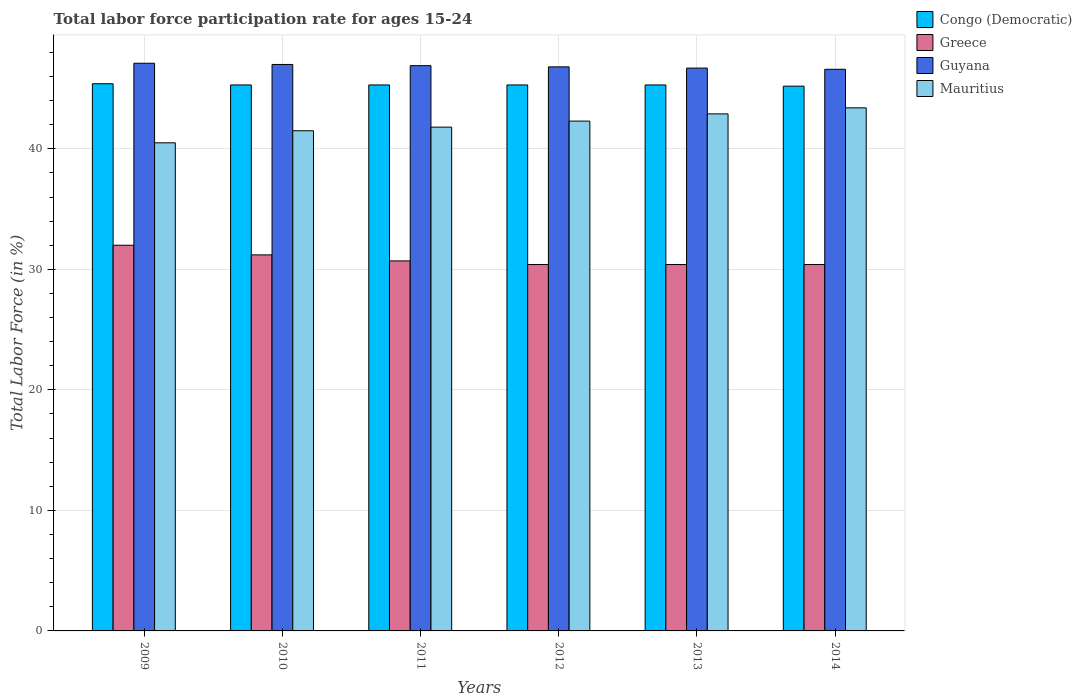How many groups of bars are there?
Keep it short and to the point. 6. Are the number of bars on each tick of the X-axis equal?
Ensure brevity in your answer.  Yes. How many bars are there on the 4th tick from the left?
Give a very brief answer. 4. What is the label of the 3rd group of bars from the left?
Give a very brief answer. 2011. In how many cases, is the number of bars for a given year not equal to the number of legend labels?
Keep it short and to the point. 0. Across all years, what is the maximum labor force participation rate in Mauritius?
Your answer should be compact. 43.4. Across all years, what is the minimum labor force participation rate in Mauritius?
Make the answer very short. 40.5. In which year was the labor force participation rate in Congo (Democratic) minimum?
Provide a short and direct response. 2014. What is the total labor force participation rate in Congo (Democratic) in the graph?
Keep it short and to the point. 271.8. What is the difference between the labor force participation rate in Greece in 2009 and that in 2014?
Provide a succinct answer. 1.6. What is the difference between the labor force participation rate in Greece in 2014 and the labor force participation rate in Guyana in 2013?
Give a very brief answer. -16.3. What is the average labor force participation rate in Greece per year?
Provide a short and direct response. 30.85. In the year 2014, what is the difference between the labor force participation rate in Mauritius and labor force participation rate in Greece?
Provide a short and direct response. 13. What is the ratio of the labor force participation rate in Guyana in 2009 to that in 2010?
Your answer should be very brief. 1. Is the difference between the labor force participation rate in Mauritius in 2011 and 2014 greater than the difference between the labor force participation rate in Greece in 2011 and 2014?
Offer a terse response. No. What is the difference between the highest and the second highest labor force participation rate in Mauritius?
Provide a succinct answer. 0.5. What is the difference between the highest and the lowest labor force participation rate in Greece?
Provide a short and direct response. 1.6. In how many years, is the labor force participation rate in Mauritius greater than the average labor force participation rate in Mauritius taken over all years?
Provide a succinct answer. 3. Is it the case that in every year, the sum of the labor force participation rate in Guyana and labor force participation rate in Congo (Democratic) is greater than the sum of labor force participation rate in Mauritius and labor force participation rate in Greece?
Provide a short and direct response. Yes. What does the 1st bar from the left in 2014 represents?
Ensure brevity in your answer.  Congo (Democratic). What does the 2nd bar from the right in 2012 represents?
Keep it short and to the point. Guyana. Is it the case that in every year, the sum of the labor force participation rate in Guyana and labor force participation rate in Greece is greater than the labor force participation rate in Congo (Democratic)?
Give a very brief answer. Yes. How many bars are there?
Provide a short and direct response. 24. What is the difference between two consecutive major ticks on the Y-axis?
Your response must be concise. 10. Are the values on the major ticks of Y-axis written in scientific E-notation?
Offer a terse response. No. How many legend labels are there?
Your response must be concise. 4. How are the legend labels stacked?
Ensure brevity in your answer.  Vertical. What is the title of the graph?
Your answer should be very brief. Total labor force participation rate for ages 15-24. What is the label or title of the X-axis?
Your answer should be compact. Years. What is the Total Labor Force (in %) of Congo (Democratic) in 2009?
Make the answer very short. 45.4. What is the Total Labor Force (in %) of Guyana in 2009?
Offer a terse response. 47.1. What is the Total Labor Force (in %) in Mauritius in 2009?
Your answer should be compact. 40.5. What is the Total Labor Force (in %) of Congo (Democratic) in 2010?
Offer a very short reply. 45.3. What is the Total Labor Force (in %) of Greece in 2010?
Your answer should be compact. 31.2. What is the Total Labor Force (in %) of Guyana in 2010?
Your response must be concise. 47. What is the Total Labor Force (in %) of Mauritius in 2010?
Your answer should be very brief. 41.5. What is the Total Labor Force (in %) of Congo (Democratic) in 2011?
Ensure brevity in your answer.  45.3. What is the Total Labor Force (in %) in Greece in 2011?
Your response must be concise. 30.7. What is the Total Labor Force (in %) in Guyana in 2011?
Offer a very short reply. 46.9. What is the Total Labor Force (in %) in Mauritius in 2011?
Your answer should be very brief. 41.8. What is the Total Labor Force (in %) in Congo (Democratic) in 2012?
Provide a succinct answer. 45.3. What is the Total Labor Force (in %) in Greece in 2012?
Provide a succinct answer. 30.4. What is the Total Labor Force (in %) of Guyana in 2012?
Offer a very short reply. 46.8. What is the Total Labor Force (in %) of Mauritius in 2012?
Provide a succinct answer. 42.3. What is the Total Labor Force (in %) of Congo (Democratic) in 2013?
Give a very brief answer. 45.3. What is the Total Labor Force (in %) in Greece in 2013?
Provide a succinct answer. 30.4. What is the Total Labor Force (in %) of Guyana in 2013?
Offer a terse response. 46.7. What is the Total Labor Force (in %) in Mauritius in 2013?
Provide a short and direct response. 42.9. What is the Total Labor Force (in %) in Congo (Democratic) in 2014?
Provide a succinct answer. 45.2. What is the Total Labor Force (in %) of Greece in 2014?
Provide a succinct answer. 30.4. What is the Total Labor Force (in %) of Guyana in 2014?
Your response must be concise. 46.6. What is the Total Labor Force (in %) in Mauritius in 2014?
Provide a succinct answer. 43.4. Across all years, what is the maximum Total Labor Force (in %) of Congo (Democratic)?
Provide a short and direct response. 45.4. Across all years, what is the maximum Total Labor Force (in %) of Greece?
Make the answer very short. 32. Across all years, what is the maximum Total Labor Force (in %) in Guyana?
Your answer should be very brief. 47.1. Across all years, what is the maximum Total Labor Force (in %) of Mauritius?
Keep it short and to the point. 43.4. Across all years, what is the minimum Total Labor Force (in %) in Congo (Democratic)?
Keep it short and to the point. 45.2. Across all years, what is the minimum Total Labor Force (in %) in Greece?
Keep it short and to the point. 30.4. Across all years, what is the minimum Total Labor Force (in %) in Guyana?
Provide a succinct answer. 46.6. Across all years, what is the minimum Total Labor Force (in %) in Mauritius?
Provide a short and direct response. 40.5. What is the total Total Labor Force (in %) in Congo (Democratic) in the graph?
Make the answer very short. 271.8. What is the total Total Labor Force (in %) of Greece in the graph?
Offer a very short reply. 185.1. What is the total Total Labor Force (in %) in Guyana in the graph?
Provide a short and direct response. 281.1. What is the total Total Labor Force (in %) in Mauritius in the graph?
Provide a short and direct response. 252.4. What is the difference between the Total Labor Force (in %) in Greece in 2009 and that in 2010?
Your answer should be very brief. 0.8. What is the difference between the Total Labor Force (in %) of Greece in 2009 and that in 2011?
Keep it short and to the point. 1.3. What is the difference between the Total Labor Force (in %) in Guyana in 2009 and that in 2011?
Offer a very short reply. 0.2. What is the difference between the Total Labor Force (in %) of Mauritius in 2009 and that in 2011?
Provide a succinct answer. -1.3. What is the difference between the Total Labor Force (in %) of Congo (Democratic) in 2009 and that in 2012?
Your response must be concise. 0.1. What is the difference between the Total Labor Force (in %) of Congo (Democratic) in 2009 and that in 2013?
Your response must be concise. 0.1. What is the difference between the Total Labor Force (in %) in Guyana in 2009 and that in 2013?
Ensure brevity in your answer.  0.4. What is the difference between the Total Labor Force (in %) of Greece in 2009 and that in 2014?
Provide a short and direct response. 1.6. What is the difference between the Total Labor Force (in %) of Mauritius in 2009 and that in 2014?
Give a very brief answer. -2.9. What is the difference between the Total Labor Force (in %) of Congo (Democratic) in 2010 and that in 2011?
Your response must be concise. 0. What is the difference between the Total Labor Force (in %) of Greece in 2010 and that in 2011?
Your answer should be compact. 0.5. What is the difference between the Total Labor Force (in %) of Guyana in 2010 and that in 2011?
Keep it short and to the point. 0.1. What is the difference between the Total Labor Force (in %) in Mauritius in 2010 and that in 2011?
Provide a succinct answer. -0.3. What is the difference between the Total Labor Force (in %) of Greece in 2010 and that in 2012?
Your answer should be very brief. 0.8. What is the difference between the Total Labor Force (in %) in Guyana in 2010 and that in 2012?
Provide a succinct answer. 0.2. What is the difference between the Total Labor Force (in %) of Greece in 2010 and that in 2013?
Offer a very short reply. 0.8. What is the difference between the Total Labor Force (in %) of Guyana in 2010 and that in 2013?
Your answer should be very brief. 0.3. What is the difference between the Total Labor Force (in %) of Mauritius in 2010 and that in 2013?
Make the answer very short. -1.4. What is the difference between the Total Labor Force (in %) of Greece in 2010 and that in 2014?
Provide a short and direct response. 0.8. What is the difference between the Total Labor Force (in %) of Guyana in 2010 and that in 2014?
Give a very brief answer. 0.4. What is the difference between the Total Labor Force (in %) in Mauritius in 2010 and that in 2014?
Your response must be concise. -1.9. What is the difference between the Total Labor Force (in %) in Congo (Democratic) in 2011 and that in 2012?
Ensure brevity in your answer.  0. What is the difference between the Total Labor Force (in %) in Mauritius in 2011 and that in 2012?
Your response must be concise. -0.5. What is the difference between the Total Labor Force (in %) in Greece in 2011 and that in 2013?
Offer a very short reply. 0.3. What is the difference between the Total Labor Force (in %) of Mauritius in 2011 and that in 2013?
Offer a very short reply. -1.1. What is the difference between the Total Labor Force (in %) of Congo (Democratic) in 2011 and that in 2014?
Offer a very short reply. 0.1. What is the difference between the Total Labor Force (in %) in Greece in 2011 and that in 2014?
Provide a succinct answer. 0.3. What is the difference between the Total Labor Force (in %) in Mauritius in 2011 and that in 2014?
Ensure brevity in your answer.  -1.6. What is the difference between the Total Labor Force (in %) of Congo (Democratic) in 2012 and that in 2013?
Give a very brief answer. 0. What is the difference between the Total Labor Force (in %) of Greece in 2012 and that in 2013?
Make the answer very short. 0. What is the difference between the Total Labor Force (in %) of Congo (Democratic) in 2012 and that in 2014?
Offer a terse response. 0.1. What is the difference between the Total Labor Force (in %) in Guyana in 2012 and that in 2014?
Provide a succinct answer. 0.2. What is the difference between the Total Labor Force (in %) of Congo (Democratic) in 2013 and that in 2014?
Keep it short and to the point. 0.1. What is the difference between the Total Labor Force (in %) of Greece in 2013 and that in 2014?
Your response must be concise. 0. What is the difference between the Total Labor Force (in %) of Mauritius in 2013 and that in 2014?
Provide a succinct answer. -0.5. What is the difference between the Total Labor Force (in %) of Congo (Democratic) in 2009 and the Total Labor Force (in %) of Greece in 2010?
Your answer should be very brief. 14.2. What is the difference between the Total Labor Force (in %) in Greece in 2009 and the Total Labor Force (in %) in Mauritius in 2010?
Provide a succinct answer. -9.5. What is the difference between the Total Labor Force (in %) in Guyana in 2009 and the Total Labor Force (in %) in Mauritius in 2010?
Offer a terse response. 5.6. What is the difference between the Total Labor Force (in %) in Greece in 2009 and the Total Labor Force (in %) in Guyana in 2011?
Ensure brevity in your answer.  -14.9. What is the difference between the Total Labor Force (in %) of Guyana in 2009 and the Total Labor Force (in %) of Mauritius in 2011?
Your answer should be compact. 5.3. What is the difference between the Total Labor Force (in %) of Congo (Democratic) in 2009 and the Total Labor Force (in %) of Greece in 2012?
Make the answer very short. 15. What is the difference between the Total Labor Force (in %) of Congo (Democratic) in 2009 and the Total Labor Force (in %) of Guyana in 2012?
Provide a succinct answer. -1.4. What is the difference between the Total Labor Force (in %) in Greece in 2009 and the Total Labor Force (in %) in Guyana in 2012?
Provide a short and direct response. -14.8. What is the difference between the Total Labor Force (in %) in Greece in 2009 and the Total Labor Force (in %) in Mauritius in 2012?
Your response must be concise. -10.3. What is the difference between the Total Labor Force (in %) in Congo (Democratic) in 2009 and the Total Labor Force (in %) in Greece in 2013?
Give a very brief answer. 15. What is the difference between the Total Labor Force (in %) of Greece in 2009 and the Total Labor Force (in %) of Guyana in 2013?
Keep it short and to the point. -14.7. What is the difference between the Total Labor Force (in %) of Greece in 2009 and the Total Labor Force (in %) of Mauritius in 2013?
Offer a terse response. -10.9. What is the difference between the Total Labor Force (in %) in Guyana in 2009 and the Total Labor Force (in %) in Mauritius in 2013?
Keep it short and to the point. 4.2. What is the difference between the Total Labor Force (in %) of Congo (Democratic) in 2009 and the Total Labor Force (in %) of Mauritius in 2014?
Your answer should be compact. 2. What is the difference between the Total Labor Force (in %) in Greece in 2009 and the Total Labor Force (in %) in Guyana in 2014?
Provide a succinct answer. -14.6. What is the difference between the Total Labor Force (in %) of Greece in 2009 and the Total Labor Force (in %) of Mauritius in 2014?
Provide a short and direct response. -11.4. What is the difference between the Total Labor Force (in %) in Guyana in 2009 and the Total Labor Force (in %) in Mauritius in 2014?
Your response must be concise. 3.7. What is the difference between the Total Labor Force (in %) in Congo (Democratic) in 2010 and the Total Labor Force (in %) in Greece in 2011?
Your answer should be very brief. 14.6. What is the difference between the Total Labor Force (in %) in Congo (Democratic) in 2010 and the Total Labor Force (in %) in Guyana in 2011?
Your answer should be very brief. -1.6. What is the difference between the Total Labor Force (in %) in Congo (Democratic) in 2010 and the Total Labor Force (in %) in Mauritius in 2011?
Provide a succinct answer. 3.5. What is the difference between the Total Labor Force (in %) in Greece in 2010 and the Total Labor Force (in %) in Guyana in 2011?
Provide a succinct answer. -15.7. What is the difference between the Total Labor Force (in %) of Greece in 2010 and the Total Labor Force (in %) of Mauritius in 2011?
Offer a terse response. -10.6. What is the difference between the Total Labor Force (in %) of Guyana in 2010 and the Total Labor Force (in %) of Mauritius in 2011?
Provide a succinct answer. 5.2. What is the difference between the Total Labor Force (in %) of Congo (Democratic) in 2010 and the Total Labor Force (in %) of Greece in 2012?
Ensure brevity in your answer.  14.9. What is the difference between the Total Labor Force (in %) of Congo (Democratic) in 2010 and the Total Labor Force (in %) of Guyana in 2012?
Your answer should be compact. -1.5. What is the difference between the Total Labor Force (in %) of Greece in 2010 and the Total Labor Force (in %) of Guyana in 2012?
Provide a short and direct response. -15.6. What is the difference between the Total Labor Force (in %) in Guyana in 2010 and the Total Labor Force (in %) in Mauritius in 2012?
Your answer should be compact. 4.7. What is the difference between the Total Labor Force (in %) of Congo (Democratic) in 2010 and the Total Labor Force (in %) of Mauritius in 2013?
Keep it short and to the point. 2.4. What is the difference between the Total Labor Force (in %) in Greece in 2010 and the Total Labor Force (in %) in Guyana in 2013?
Make the answer very short. -15.5. What is the difference between the Total Labor Force (in %) of Guyana in 2010 and the Total Labor Force (in %) of Mauritius in 2013?
Give a very brief answer. 4.1. What is the difference between the Total Labor Force (in %) of Congo (Democratic) in 2010 and the Total Labor Force (in %) of Mauritius in 2014?
Keep it short and to the point. 1.9. What is the difference between the Total Labor Force (in %) of Greece in 2010 and the Total Labor Force (in %) of Guyana in 2014?
Your answer should be very brief. -15.4. What is the difference between the Total Labor Force (in %) of Greece in 2010 and the Total Labor Force (in %) of Mauritius in 2014?
Offer a very short reply. -12.2. What is the difference between the Total Labor Force (in %) in Guyana in 2010 and the Total Labor Force (in %) in Mauritius in 2014?
Your response must be concise. 3.6. What is the difference between the Total Labor Force (in %) in Congo (Democratic) in 2011 and the Total Labor Force (in %) in Mauritius in 2012?
Your answer should be very brief. 3. What is the difference between the Total Labor Force (in %) in Greece in 2011 and the Total Labor Force (in %) in Guyana in 2012?
Keep it short and to the point. -16.1. What is the difference between the Total Labor Force (in %) in Greece in 2011 and the Total Labor Force (in %) in Mauritius in 2012?
Your answer should be compact. -11.6. What is the difference between the Total Labor Force (in %) in Greece in 2011 and the Total Labor Force (in %) in Guyana in 2013?
Provide a short and direct response. -16. What is the difference between the Total Labor Force (in %) of Greece in 2011 and the Total Labor Force (in %) of Mauritius in 2013?
Offer a terse response. -12.2. What is the difference between the Total Labor Force (in %) of Guyana in 2011 and the Total Labor Force (in %) of Mauritius in 2013?
Make the answer very short. 4. What is the difference between the Total Labor Force (in %) of Congo (Democratic) in 2011 and the Total Labor Force (in %) of Mauritius in 2014?
Offer a terse response. 1.9. What is the difference between the Total Labor Force (in %) in Greece in 2011 and the Total Labor Force (in %) in Guyana in 2014?
Your response must be concise. -15.9. What is the difference between the Total Labor Force (in %) of Guyana in 2011 and the Total Labor Force (in %) of Mauritius in 2014?
Ensure brevity in your answer.  3.5. What is the difference between the Total Labor Force (in %) in Congo (Democratic) in 2012 and the Total Labor Force (in %) in Guyana in 2013?
Your answer should be compact. -1.4. What is the difference between the Total Labor Force (in %) of Greece in 2012 and the Total Labor Force (in %) of Guyana in 2013?
Offer a very short reply. -16.3. What is the difference between the Total Labor Force (in %) of Greece in 2012 and the Total Labor Force (in %) of Mauritius in 2013?
Offer a terse response. -12.5. What is the difference between the Total Labor Force (in %) of Guyana in 2012 and the Total Labor Force (in %) of Mauritius in 2013?
Offer a very short reply. 3.9. What is the difference between the Total Labor Force (in %) in Congo (Democratic) in 2012 and the Total Labor Force (in %) in Guyana in 2014?
Offer a very short reply. -1.3. What is the difference between the Total Labor Force (in %) of Congo (Democratic) in 2012 and the Total Labor Force (in %) of Mauritius in 2014?
Offer a very short reply. 1.9. What is the difference between the Total Labor Force (in %) in Greece in 2012 and the Total Labor Force (in %) in Guyana in 2014?
Offer a very short reply. -16.2. What is the difference between the Total Labor Force (in %) in Congo (Democratic) in 2013 and the Total Labor Force (in %) in Guyana in 2014?
Make the answer very short. -1.3. What is the difference between the Total Labor Force (in %) in Congo (Democratic) in 2013 and the Total Labor Force (in %) in Mauritius in 2014?
Offer a very short reply. 1.9. What is the difference between the Total Labor Force (in %) of Greece in 2013 and the Total Labor Force (in %) of Guyana in 2014?
Ensure brevity in your answer.  -16.2. What is the difference between the Total Labor Force (in %) in Guyana in 2013 and the Total Labor Force (in %) in Mauritius in 2014?
Your response must be concise. 3.3. What is the average Total Labor Force (in %) of Congo (Democratic) per year?
Your answer should be very brief. 45.3. What is the average Total Labor Force (in %) in Greece per year?
Your answer should be very brief. 30.85. What is the average Total Labor Force (in %) of Guyana per year?
Make the answer very short. 46.85. What is the average Total Labor Force (in %) of Mauritius per year?
Provide a succinct answer. 42.07. In the year 2009, what is the difference between the Total Labor Force (in %) in Congo (Democratic) and Total Labor Force (in %) in Greece?
Your answer should be very brief. 13.4. In the year 2009, what is the difference between the Total Labor Force (in %) in Congo (Democratic) and Total Labor Force (in %) in Guyana?
Your answer should be very brief. -1.7. In the year 2009, what is the difference between the Total Labor Force (in %) in Greece and Total Labor Force (in %) in Guyana?
Offer a very short reply. -15.1. In the year 2009, what is the difference between the Total Labor Force (in %) in Greece and Total Labor Force (in %) in Mauritius?
Offer a very short reply. -8.5. In the year 2010, what is the difference between the Total Labor Force (in %) in Congo (Democratic) and Total Labor Force (in %) in Guyana?
Offer a very short reply. -1.7. In the year 2010, what is the difference between the Total Labor Force (in %) in Congo (Democratic) and Total Labor Force (in %) in Mauritius?
Provide a short and direct response. 3.8. In the year 2010, what is the difference between the Total Labor Force (in %) in Greece and Total Labor Force (in %) in Guyana?
Offer a terse response. -15.8. In the year 2010, what is the difference between the Total Labor Force (in %) of Guyana and Total Labor Force (in %) of Mauritius?
Keep it short and to the point. 5.5. In the year 2011, what is the difference between the Total Labor Force (in %) of Congo (Democratic) and Total Labor Force (in %) of Guyana?
Ensure brevity in your answer.  -1.6. In the year 2011, what is the difference between the Total Labor Force (in %) of Congo (Democratic) and Total Labor Force (in %) of Mauritius?
Your response must be concise. 3.5. In the year 2011, what is the difference between the Total Labor Force (in %) of Greece and Total Labor Force (in %) of Guyana?
Offer a very short reply. -16.2. In the year 2011, what is the difference between the Total Labor Force (in %) in Greece and Total Labor Force (in %) in Mauritius?
Your response must be concise. -11.1. In the year 2012, what is the difference between the Total Labor Force (in %) of Congo (Democratic) and Total Labor Force (in %) of Guyana?
Provide a short and direct response. -1.5. In the year 2012, what is the difference between the Total Labor Force (in %) in Congo (Democratic) and Total Labor Force (in %) in Mauritius?
Keep it short and to the point. 3. In the year 2012, what is the difference between the Total Labor Force (in %) of Greece and Total Labor Force (in %) of Guyana?
Offer a terse response. -16.4. In the year 2013, what is the difference between the Total Labor Force (in %) in Congo (Democratic) and Total Labor Force (in %) in Greece?
Keep it short and to the point. 14.9. In the year 2013, what is the difference between the Total Labor Force (in %) in Greece and Total Labor Force (in %) in Guyana?
Offer a terse response. -16.3. In the year 2013, what is the difference between the Total Labor Force (in %) of Greece and Total Labor Force (in %) of Mauritius?
Offer a very short reply. -12.5. In the year 2014, what is the difference between the Total Labor Force (in %) of Congo (Democratic) and Total Labor Force (in %) of Greece?
Your answer should be very brief. 14.8. In the year 2014, what is the difference between the Total Labor Force (in %) of Congo (Democratic) and Total Labor Force (in %) of Guyana?
Offer a very short reply. -1.4. In the year 2014, what is the difference between the Total Labor Force (in %) in Greece and Total Labor Force (in %) in Guyana?
Make the answer very short. -16.2. What is the ratio of the Total Labor Force (in %) in Greece in 2009 to that in 2010?
Make the answer very short. 1.03. What is the ratio of the Total Labor Force (in %) of Mauritius in 2009 to that in 2010?
Give a very brief answer. 0.98. What is the ratio of the Total Labor Force (in %) of Greece in 2009 to that in 2011?
Your answer should be compact. 1.04. What is the ratio of the Total Labor Force (in %) in Mauritius in 2009 to that in 2011?
Your answer should be very brief. 0.97. What is the ratio of the Total Labor Force (in %) in Congo (Democratic) in 2009 to that in 2012?
Your answer should be very brief. 1. What is the ratio of the Total Labor Force (in %) in Greece in 2009 to that in 2012?
Make the answer very short. 1.05. What is the ratio of the Total Labor Force (in %) of Guyana in 2009 to that in 2012?
Ensure brevity in your answer.  1.01. What is the ratio of the Total Labor Force (in %) in Mauritius in 2009 to that in 2012?
Keep it short and to the point. 0.96. What is the ratio of the Total Labor Force (in %) of Congo (Democratic) in 2009 to that in 2013?
Provide a short and direct response. 1. What is the ratio of the Total Labor Force (in %) in Greece in 2009 to that in 2013?
Make the answer very short. 1.05. What is the ratio of the Total Labor Force (in %) in Guyana in 2009 to that in 2013?
Provide a short and direct response. 1.01. What is the ratio of the Total Labor Force (in %) in Mauritius in 2009 to that in 2013?
Your answer should be very brief. 0.94. What is the ratio of the Total Labor Force (in %) of Greece in 2009 to that in 2014?
Your response must be concise. 1.05. What is the ratio of the Total Labor Force (in %) in Guyana in 2009 to that in 2014?
Your response must be concise. 1.01. What is the ratio of the Total Labor Force (in %) in Mauritius in 2009 to that in 2014?
Your answer should be very brief. 0.93. What is the ratio of the Total Labor Force (in %) of Greece in 2010 to that in 2011?
Your answer should be compact. 1.02. What is the ratio of the Total Labor Force (in %) in Greece in 2010 to that in 2012?
Make the answer very short. 1.03. What is the ratio of the Total Labor Force (in %) of Guyana in 2010 to that in 2012?
Your answer should be compact. 1. What is the ratio of the Total Labor Force (in %) of Mauritius in 2010 to that in 2012?
Your answer should be very brief. 0.98. What is the ratio of the Total Labor Force (in %) in Congo (Democratic) in 2010 to that in 2013?
Provide a short and direct response. 1. What is the ratio of the Total Labor Force (in %) of Greece in 2010 to that in 2013?
Provide a short and direct response. 1.03. What is the ratio of the Total Labor Force (in %) of Guyana in 2010 to that in 2013?
Offer a very short reply. 1.01. What is the ratio of the Total Labor Force (in %) of Mauritius in 2010 to that in 2013?
Your response must be concise. 0.97. What is the ratio of the Total Labor Force (in %) in Congo (Democratic) in 2010 to that in 2014?
Offer a terse response. 1. What is the ratio of the Total Labor Force (in %) in Greece in 2010 to that in 2014?
Provide a succinct answer. 1.03. What is the ratio of the Total Labor Force (in %) of Guyana in 2010 to that in 2014?
Your answer should be very brief. 1.01. What is the ratio of the Total Labor Force (in %) of Mauritius in 2010 to that in 2014?
Provide a succinct answer. 0.96. What is the ratio of the Total Labor Force (in %) of Congo (Democratic) in 2011 to that in 2012?
Provide a short and direct response. 1. What is the ratio of the Total Labor Force (in %) in Greece in 2011 to that in 2012?
Your answer should be very brief. 1.01. What is the ratio of the Total Labor Force (in %) in Guyana in 2011 to that in 2012?
Provide a short and direct response. 1. What is the ratio of the Total Labor Force (in %) of Mauritius in 2011 to that in 2012?
Offer a very short reply. 0.99. What is the ratio of the Total Labor Force (in %) in Greece in 2011 to that in 2013?
Offer a very short reply. 1.01. What is the ratio of the Total Labor Force (in %) of Mauritius in 2011 to that in 2013?
Your response must be concise. 0.97. What is the ratio of the Total Labor Force (in %) of Congo (Democratic) in 2011 to that in 2014?
Offer a terse response. 1. What is the ratio of the Total Labor Force (in %) of Greece in 2011 to that in 2014?
Your answer should be compact. 1.01. What is the ratio of the Total Labor Force (in %) in Guyana in 2011 to that in 2014?
Ensure brevity in your answer.  1.01. What is the ratio of the Total Labor Force (in %) in Mauritius in 2011 to that in 2014?
Keep it short and to the point. 0.96. What is the ratio of the Total Labor Force (in %) in Congo (Democratic) in 2012 to that in 2013?
Make the answer very short. 1. What is the ratio of the Total Labor Force (in %) in Greece in 2012 to that in 2013?
Your answer should be compact. 1. What is the ratio of the Total Labor Force (in %) in Guyana in 2012 to that in 2013?
Make the answer very short. 1. What is the ratio of the Total Labor Force (in %) of Mauritius in 2012 to that in 2013?
Your answer should be very brief. 0.99. What is the ratio of the Total Labor Force (in %) of Congo (Democratic) in 2012 to that in 2014?
Ensure brevity in your answer.  1. What is the ratio of the Total Labor Force (in %) in Greece in 2012 to that in 2014?
Provide a short and direct response. 1. What is the ratio of the Total Labor Force (in %) in Mauritius in 2012 to that in 2014?
Keep it short and to the point. 0.97. What is the difference between the highest and the second highest Total Labor Force (in %) in Guyana?
Keep it short and to the point. 0.1. What is the difference between the highest and the lowest Total Labor Force (in %) in Guyana?
Provide a succinct answer. 0.5. 